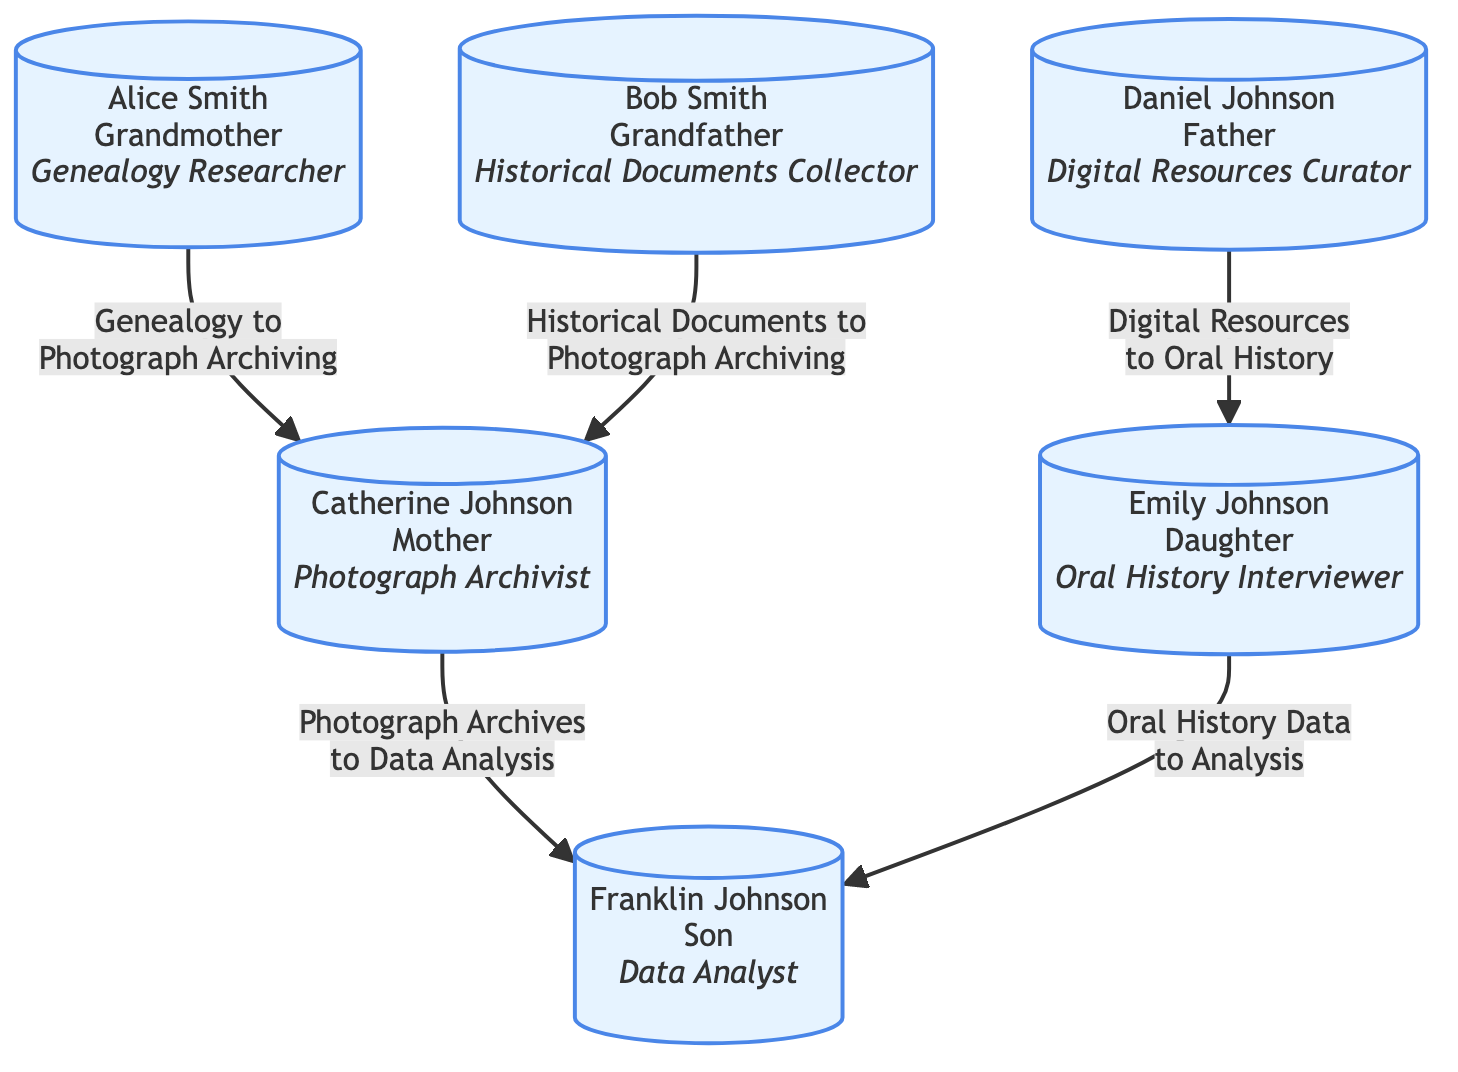What's the role of Alice Smith? By examining the node labeled "Alice Smith," we see the designated role is "Genealogy Researcher."
Answer: Genealogy Researcher How many individuals are involved in the family tree? Counting the nodes in the diagram, we find there are a total of six individuals listed.
Answer: 6 What is the relationship of Franklin Johnson to Alice Smith? Looking through the family relations, Franklin Johnson is identified as the son of Catherine Johnson, who is the child of Alice Smith, making Franklin Smith her grandson.
Answer: Grandson Which family member collaborates with Franklin Johnson on data analysis? The edge from Emily Johnson to Franklin Johnson indicates collaboration, noting that Emily's role involves providing "Oral History Data" to be analyzed.
Answer: Emily Johnson What type of resources does Daniel Johnson curate? The node for "Daniel Johnson" shows he serves as the "Digital Resources Curator," indicating the nature of his engagement with research materials.
Answer: Digital Resources How many collaboration edges are shown in the diagram? There are five connections (edges) drawn between individuals that illustrate their collaborative efforts and resource flow in the research process.
Answer: 5 Who collaborates with Catherine Johnson on photograph archiving? The edges reveal that both Alice Smith and Bob Smith contribute to Catherine Johnson's work in photograph archiving through genealogy and historical documents respectively.
Answer: Alice Smith and Bob Smith Which two roles are directly connected in the collaboration for oral history? Examining the edges, we see that Daniel Johnson (Digital Resources Curator) collaborates with Emily Johnson (Oral History Interviewer) on gathering related resources.
Answer: Daniel Johnson and Emily Johnson What is the flow of resources from Photograph Archives? The edge from Catherine Johnson to Franklin Johnson states the collaboration is "Photograph Archives to Data Analysis," indicating the direction of resource flow is from photograph archiving to analysis.
Answer: Photograph Archives to Data Analysis 